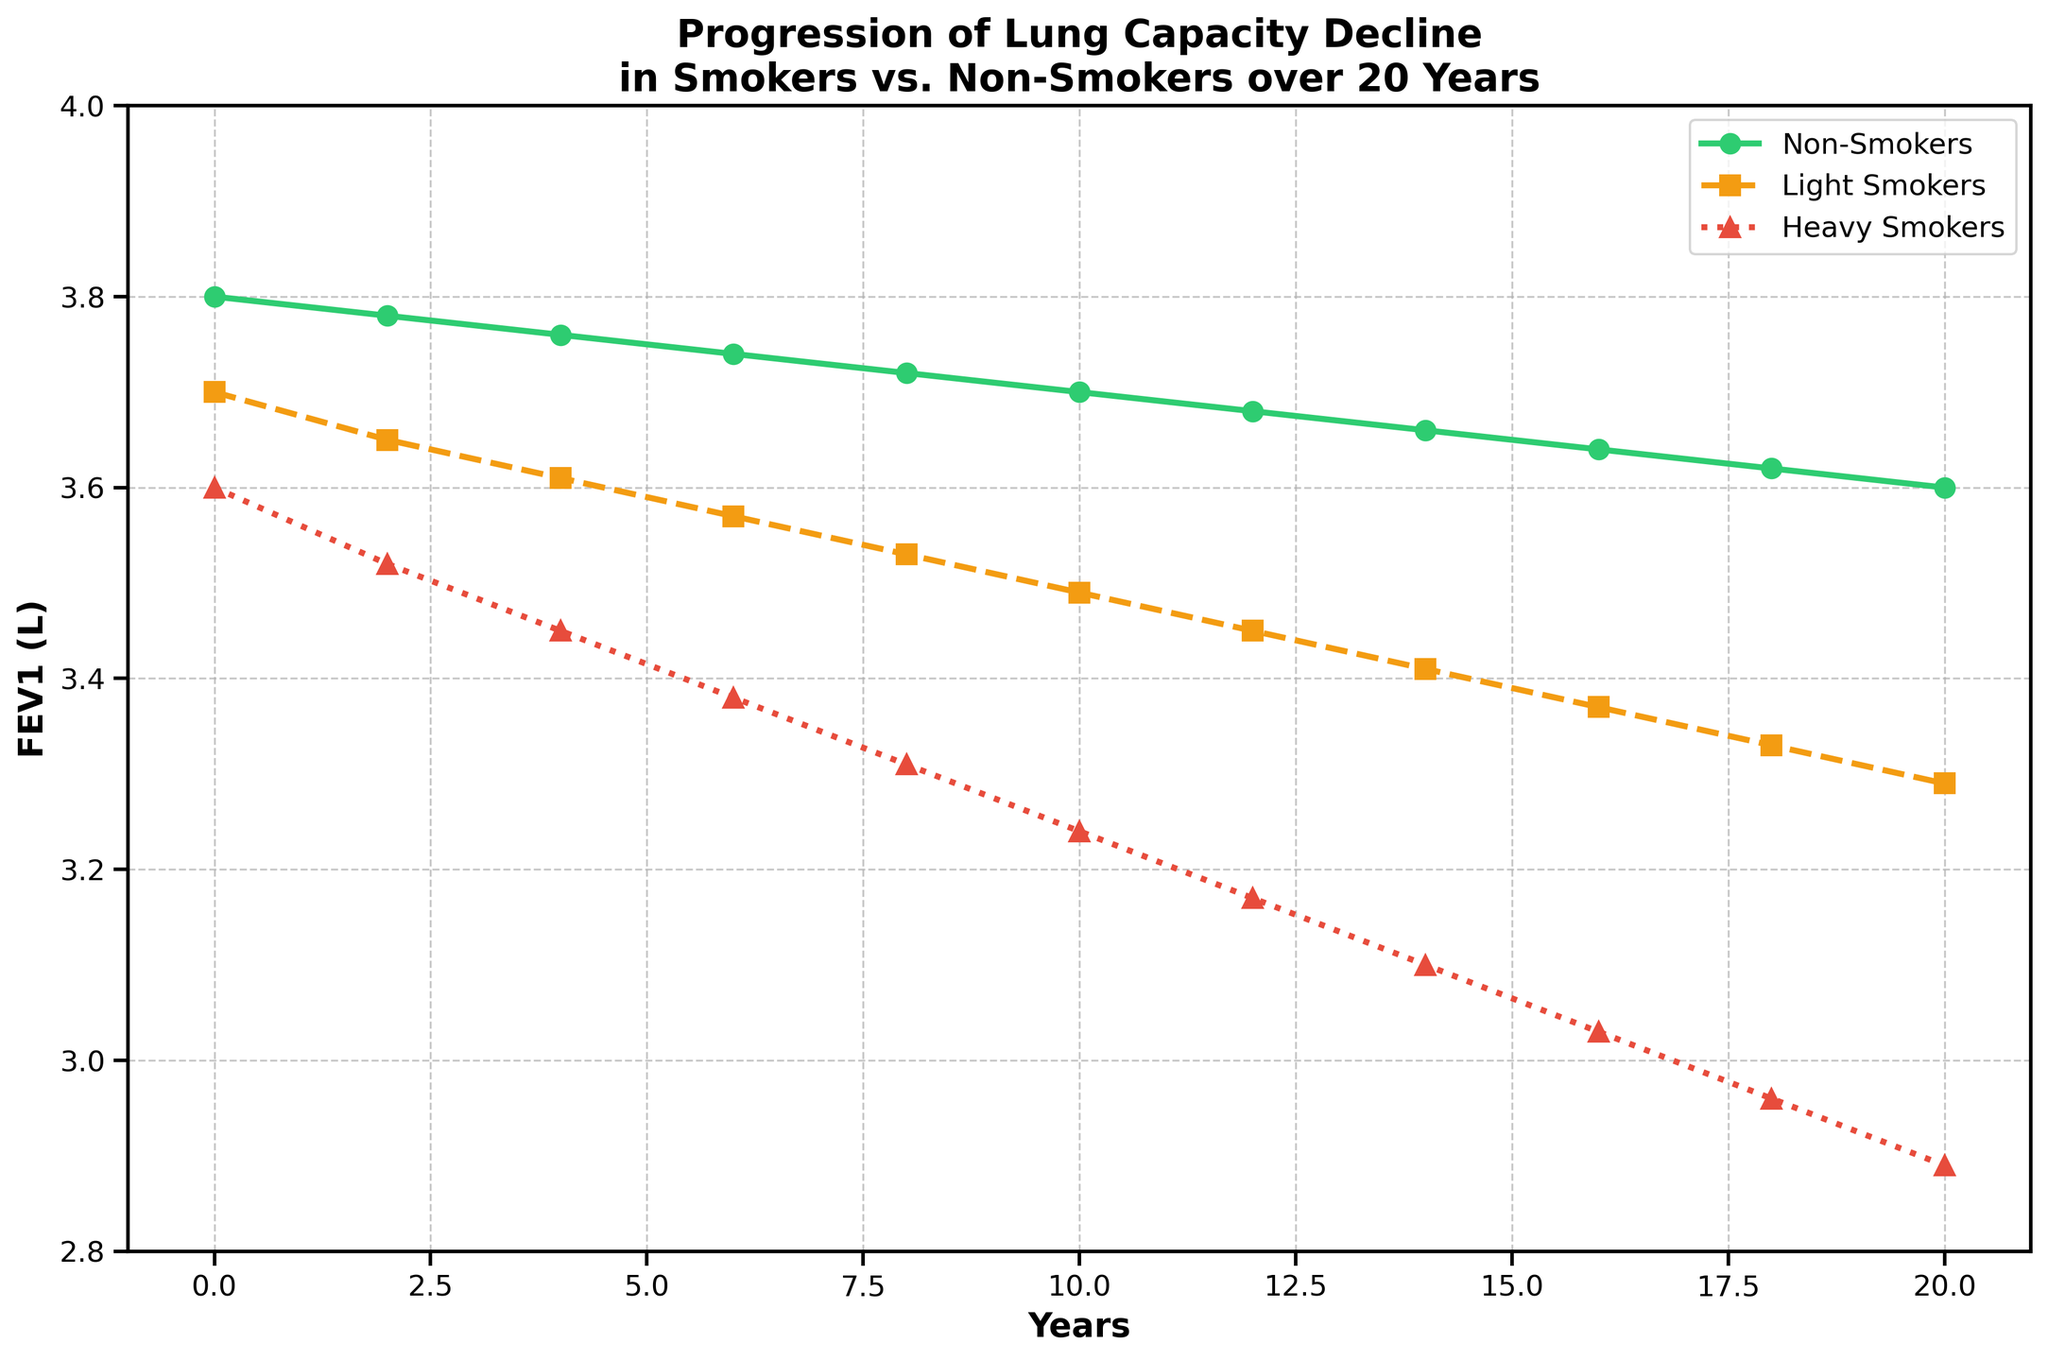What are the FEV1 values for heavy smokers and non-smokers at Year 10? To identify the FEV1 values for heavy smokers and non-smokers at Year 10, locate Year 10 on the x-axis and then follow the paths of the respective lines (heavy smokers: red dotted line, non-smokers: green solid line) vertically to the y-axis. The FEV1 values at Year 10 for heavy smokers and non-smokers are 3.24 L and 3.70 L, respectively.
Answer: Heavy smokers: 3.24 L, Non-smokers: 3.70 L By how much does the FEV1 decrease for light smokers from Year 0 to Year 20? Determine the FEV1 values at Year 0 and Year 20 for light smokers (yellow dashed line), which are 3.7 L and 3.29 L, respectively. Subtract the FEV1 at Year 20 from Year 0: 3.7 L - 3.29 L = 0.41 L.
Answer: 0.41 L What is the average FEV1 value of non-smokers over the entire period? Sum the FEV1 values for non-smokers at each recorded year: 3.8 + 3.78 + 3.76 + 3.74 + 3.72 + 3.70 + 3.68 + 3.66 + 3.64 + 3.62 + 3.60 = 37.7. Divide the sum by the number of years (11): 37.7 / 11 ≈ 3.43 L.
Answer: ≈ 3.43 L Which group shows the steepest decline in FEV1 and over what time period do they show the largest drop? The steepest decline is indicated by the slope of the line. The red dotted line (heavy smokers) shows the steepest decline. Over the entire 20-year period, the FEV1 of heavy smokers drops from 3.6 L to 2.89 L, a drop of 0.71 L.
Answer: Heavy smokers; from Year 0 to Year 20 Between Year 8 and Year 12, which group experiences the smallest decline in FEV1? Calculate the decline in FEV1 for each group between Year 8 and Year 12:
- Non-smokers: 3.72 L - 3.68 L = 0.04 L
- Light smokers: 3.53 L - 3.45 L = 0.08 L
- Heavy smokers: 3.31 L - 3.17 L = 0.14 L
Non-smokers experience the smallest decline of 0.04 L.
Answer: Non-smokers Based on the plot, which group's FEV1 remains above 3.0 L throughout the 20-year period? Observe each plotted line over the 20 years. Only the green solid line (non-smokers) and the yellow dashed line (light smokers) remain above 3.0 L throughout; the red dotted line (heavy smokers) drops below 3.0 L by Year 16.
Answer: Non-smokers and Light Smokers Which year shows the greatest difference in FEV1 between light smokers and heavy smokers? Calculate the differences in FEV1 between light smokers and heavy smokers for each year:
- Year 0: 3.7 - 3.6 = 0.1
- Year 2: 3.65 - 3.52 = 0.13
- Year 4: 3.61 - 3.45 = 0.16
- Year 6: 3.57 - 3.38 = 0.19
- Year 8: 3.53 - 3.31 = 0.22
- Year 10: 3.49 - 3.24 = 0.25
- Year 12: 3.45 - 3.17 = 0.28
- Year 14: 3.41 - 3.10 = 0.31
- Year 16: 3.37 - 3.03 = 0.34
- Year 18: 3.33 - 2.96 = 0.37
- Year 20: 3.29 - 2.89 = 0.4
The greatest difference is 0.4 L in Year 20.
Answer: Year 20 What is the approximate total decline in FEV1 for non-smokers over the 20-year period? Determine the initial FEV1 value for non-smokers at Year 0 (3.8 L) and the final value at Year 20 (3.6 L). Subtract the final from the initial: 3.8 L - 3.6 L = 0.2 L.
Answer: 0.2 L 